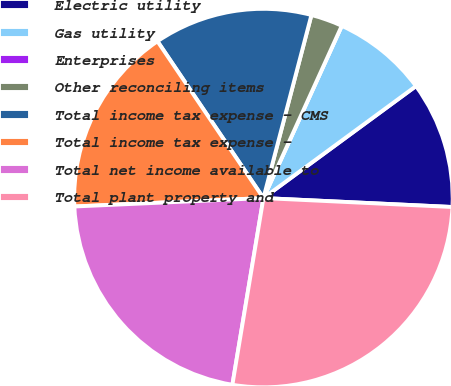Convert chart. <chart><loc_0><loc_0><loc_500><loc_500><pie_chart><fcel>Electric utility<fcel>Gas utility<fcel>Enterprises<fcel>Other reconciling items<fcel>Total income tax expense - CMS<fcel>Total income tax expense -<fcel>Total net income available to<fcel>Total plant property and<nl><fcel>10.83%<fcel>8.13%<fcel>0.0%<fcel>2.71%<fcel>13.54%<fcel>16.25%<fcel>21.67%<fcel>26.87%<nl></chart> 